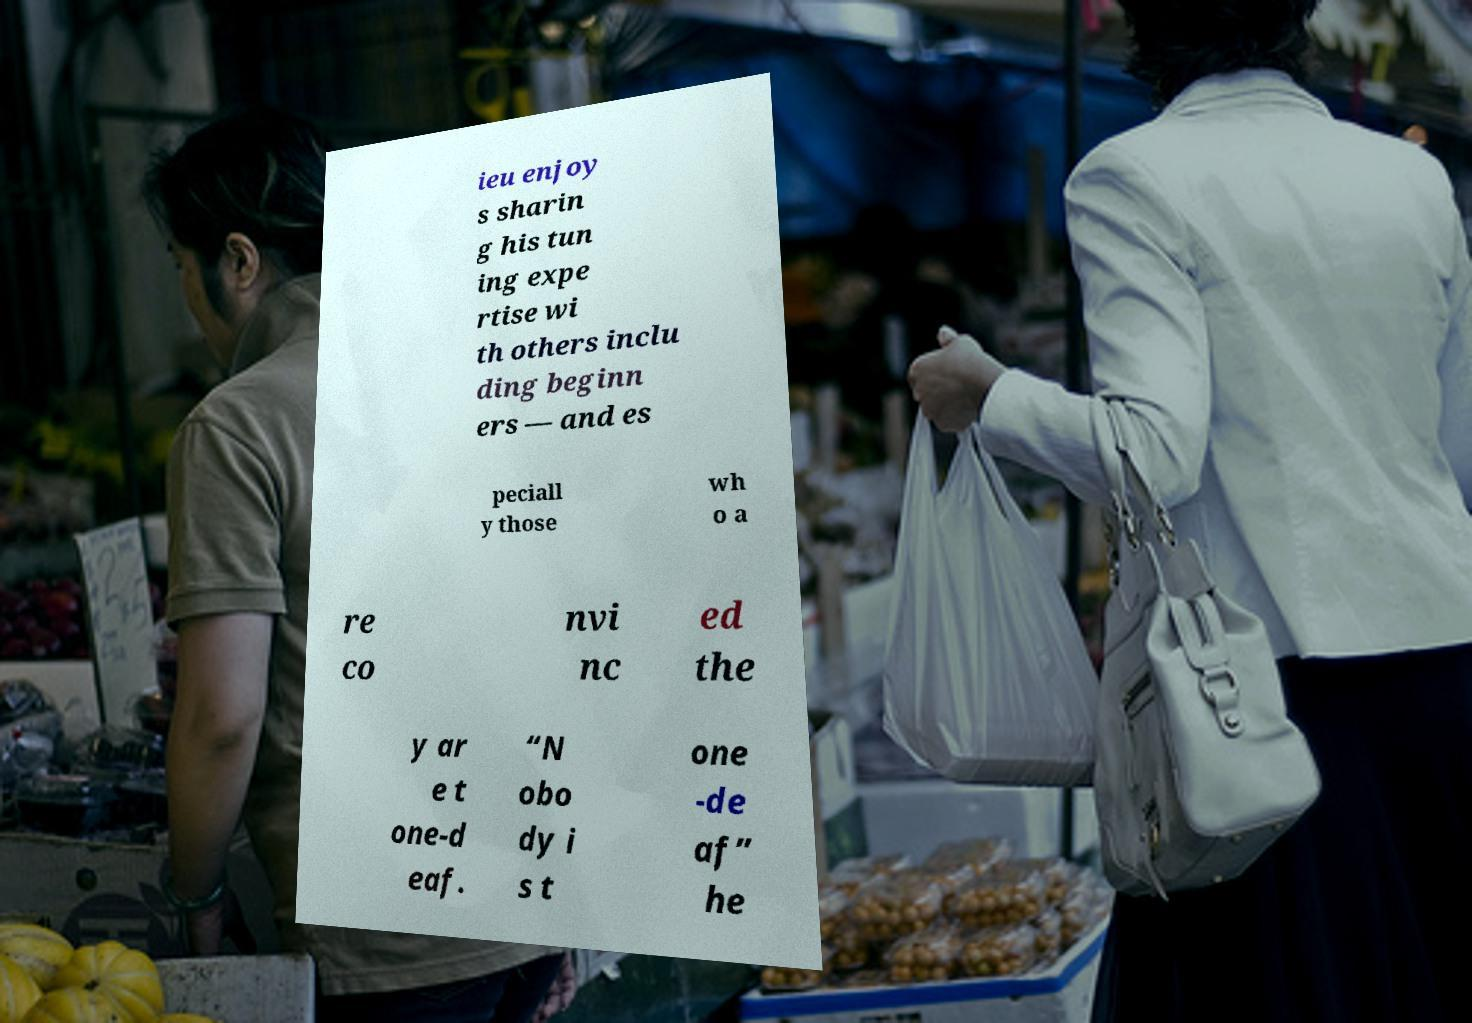What messages or text are displayed in this image? I need them in a readable, typed format. ieu enjoy s sharin g his tun ing expe rtise wi th others inclu ding beginn ers — and es peciall y those wh o a re co nvi nc ed the y ar e t one-d eaf. “N obo dy i s t one -de af” he 